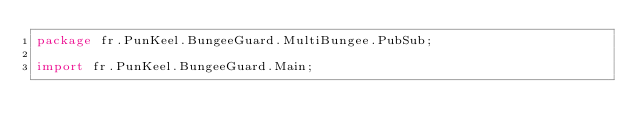<code> <loc_0><loc_0><loc_500><loc_500><_Java_>package fr.PunKeel.BungeeGuard.MultiBungee.PubSub;

import fr.PunKeel.BungeeGuard.Main;</code> 